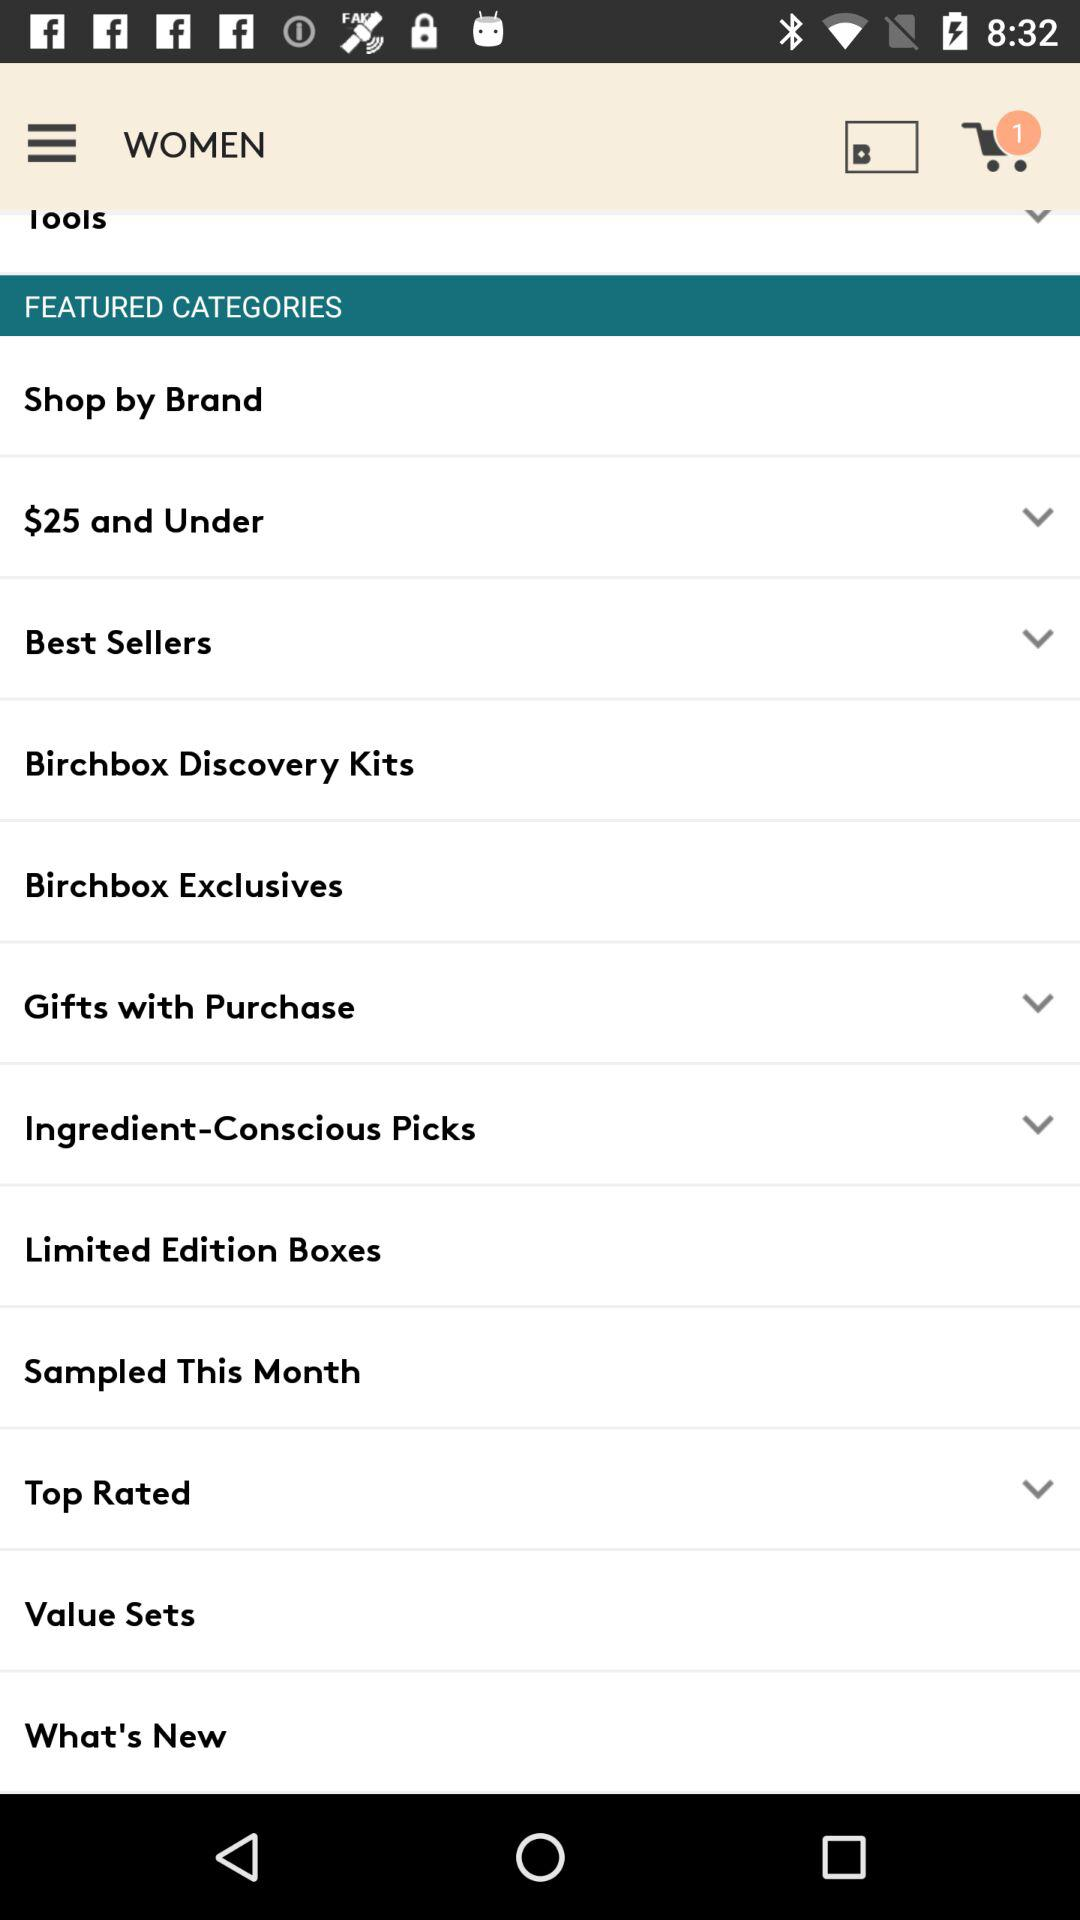How many items are there in the cart? There is 1 item. 